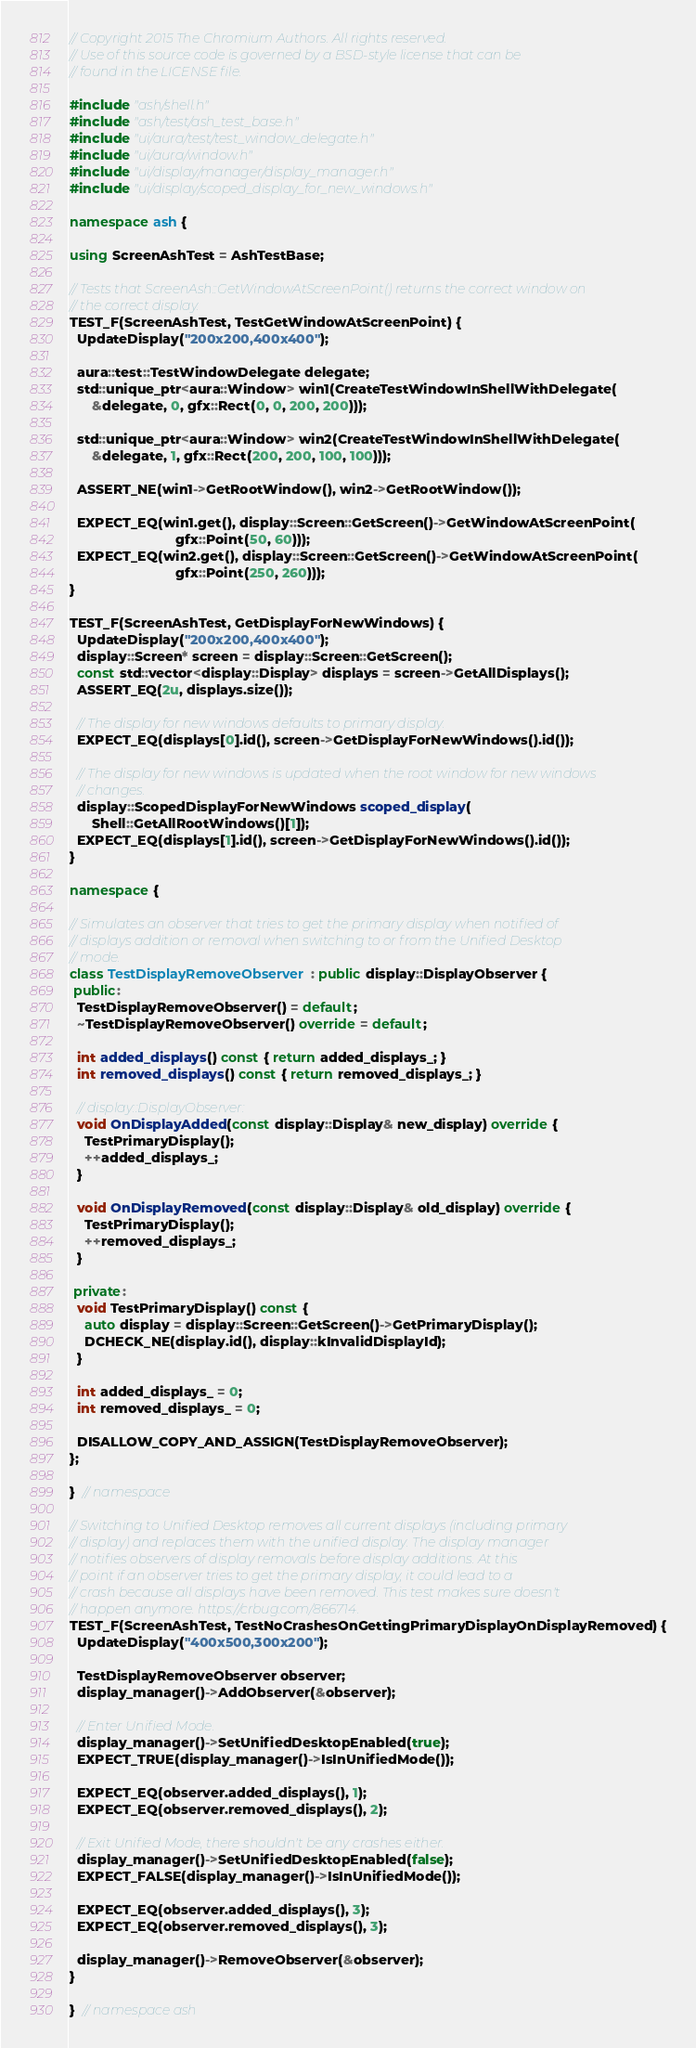Convert code to text. <code><loc_0><loc_0><loc_500><loc_500><_C++_>// Copyright 2015 The Chromium Authors. All rights reserved.
// Use of this source code is governed by a BSD-style license that can be
// found in the LICENSE file.

#include "ash/shell.h"
#include "ash/test/ash_test_base.h"
#include "ui/aura/test/test_window_delegate.h"
#include "ui/aura/window.h"
#include "ui/display/manager/display_manager.h"
#include "ui/display/scoped_display_for_new_windows.h"

namespace ash {

using ScreenAshTest = AshTestBase;

// Tests that ScreenAsh::GetWindowAtScreenPoint() returns the correct window on
// the correct display.
TEST_F(ScreenAshTest, TestGetWindowAtScreenPoint) {
  UpdateDisplay("200x200,400x400");

  aura::test::TestWindowDelegate delegate;
  std::unique_ptr<aura::Window> win1(CreateTestWindowInShellWithDelegate(
      &delegate, 0, gfx::Rect(0, 0, 200, 200)));

  std::unique_ptr<aura::Window> win2(CreateTestWindowInShellWithDelegate(
      &delegate, 1, gfx::Rect(200, 200, 100, 100)));

  ASSERT_NE(win1->GetRootWindow(), win2->GetRootWindow());

  EXPECT_EQ(win1.get(), display::Screen::GetScreen()->GetWindowAtScreenPoint(
                            gfx::Point(50, 60)));
  EXPECT_EQ(win2.get(), display::Screen::GetScreen()->GetWindowAtScreenPoint(
                            gfx::Point(250, 260)));
}

TEST_F(ScreenAshTest, GetDisplayForNewWindows) {
  UpdateDisplay("200x200,400x400");
  display::Screen* screen = display::Screen::GetScreen();
  const std::vector<display::Display> displays = screen->GetAllDisplays();
  ASSERT_EQ(2u, displays.size());

  // The display for new windows defaults to primary display.
  EXPECT_EQ(displays[0].id(), screen->GetDisplayForNewWindows().id());

  // The display for new windows is updated when the root window for new windows
  // changes.
  display::ScopedDisplayForNewWindows scoped_display(
      Shell::GetAllRootWindows()[1]);
  EXPECT_EQ(displays[1].id(), screen->GetDisplayForNewWindows().id());
}

namespace {

// Simulates an observer that tries to get the primary display when notified of
// displays addition or removal when switching to or from the Unified Desktop
// mode.
class TestDisplayRemoveObserver : public display::DisplayObserver {
 public:
  TestDisplayRemoveObserver() = default;
  ~TestDisplayRemoveObserver() override = default;

  int added_displays() const { return added_displays_; }
  int removed_displays() const { return removed_displays_; }

  // display::DisplayObserver:
  void OnDisplayAdded(const display::Display& new_display) override {
    TestPrimaryDisplay();
    ++added_displays_;
  }

  void OnDisplayRemoved(const display::Display& old_display) override {
    TestPrimaryDisplay();
    ++removed_displays_;
  }

 private:
  void TestPrimaryDisplay() const {
    auto display = display::Screen::GetScreen()->GetPrimaryDisplay();
    DCHECK_NE(display.id(), display::kInvalidDisplayId);
  }

  int added_displays_ = 0;
  int removed_displays_ = 0;

  DISALLOW_COPY_AND_ASSIGN(TestDisplayRemoveObserver);
};

}  // namespace

// Switching to Unified Desktop removes all current displays (including primary
// display) and replaces them with the unified display. The display manager
// notifies observers of display removals before display additions. At this
// point if an observer tries to get the primary display, it could lead to a
// crash because all displays have been removed. This test makes sure doesn't
// happen anymore. https://crbug.com/866714.
TEST_F(ScreenAshTest, TestNoCrashesOnGettingPrimaryDisplayOnDisplayRemoved) {
  UpdateDisplay("400x500,300x200");

  TestDisplayRemoveObserver observer;
  display_manager()->AddObserver(&observer);

  // Enter Unified Mode.
  display_manager()->SetUnifiedDesktopEnabled(true);
  EXPECT_TRUE(display_manager()->IsInUnifiedMode());

  EXPECT_EQ(observer.added_displays(), 1);
  EXPECT_EQ(observer.removed_displays(), 2);

  // Exit Unified Mode, there shouldn't be any crashes either.
  display_manager()->SetUnifiedDesktopEnabled(false);
  EXPECT_FALSE(display_manager()->IsInUnifiedMode());

  EXPECT_EQ(observer.added_displays(), 3);
  EXPECT_EQ(observer.removed_displays(), 3);

  display_manager()->RemoveObserver(&observer);
}

}  // namespace ash
</code> 